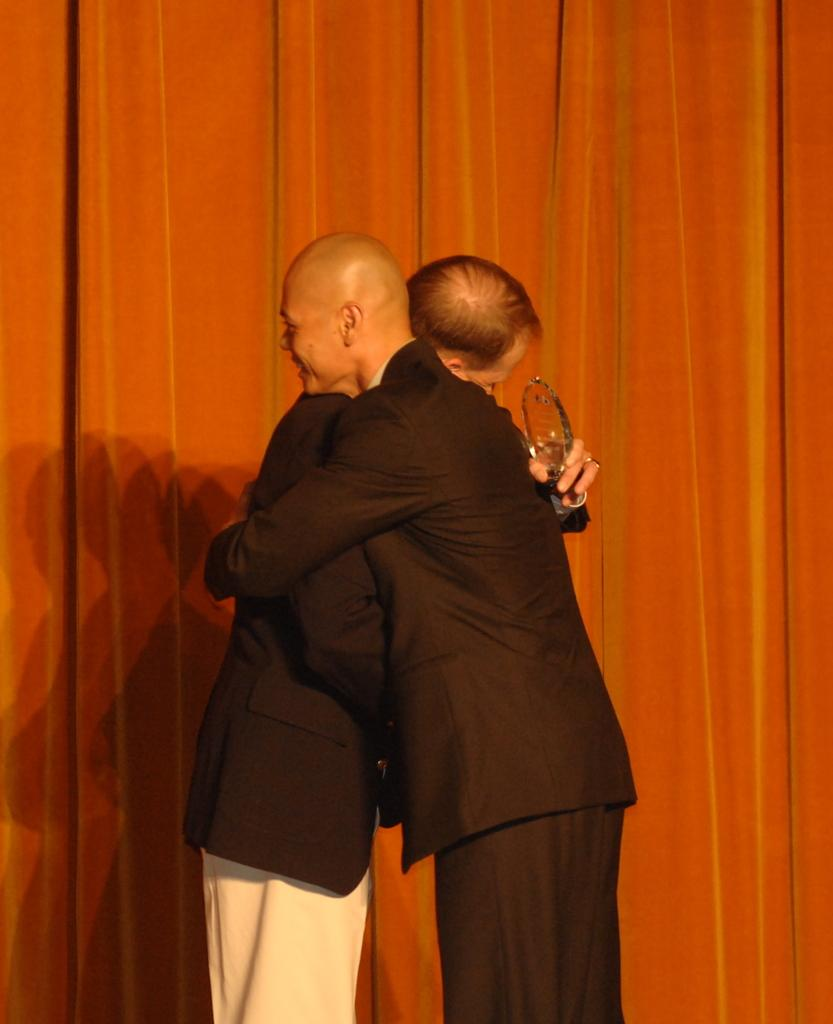How many people are in the image? There are two persons in the center of the image. What are the persons wearing? The persons are wearing suits. What are the persons doing in the image? The persons are standing and hugging each other. Can you describe any objects in the image? There is an object in the image, but its specific details are not mentioned in the facts. What can be seen in the background of the image? There are curtains in the background of the image. What type of pin is visible on the lapel of the person on the left? There is no mention of a pin in the image, so it cannot be determined if one is present or not. What industry does the person on the right work in? The facts provided do not give any information about the persons' professions or industries, so it cannot be determined. 